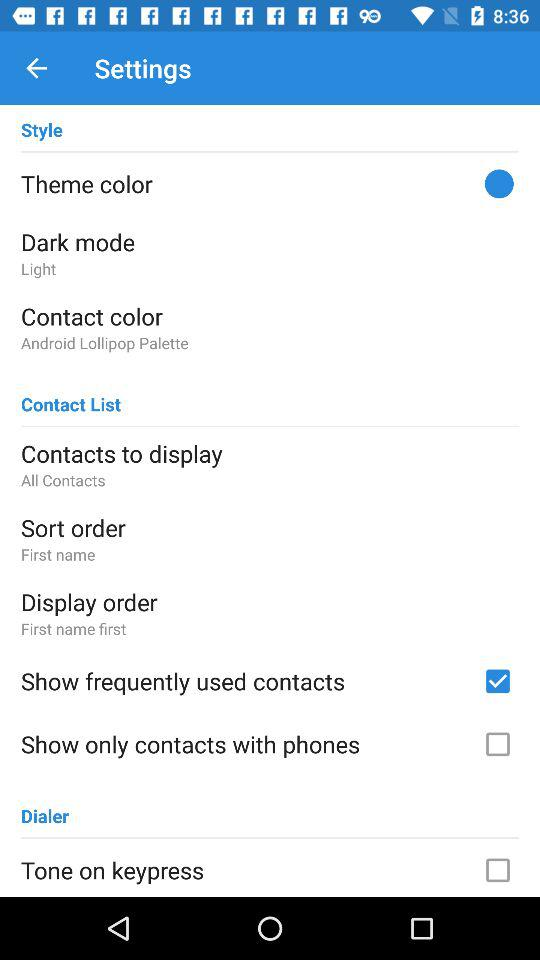What is the sort order? The sort order is "First name". 